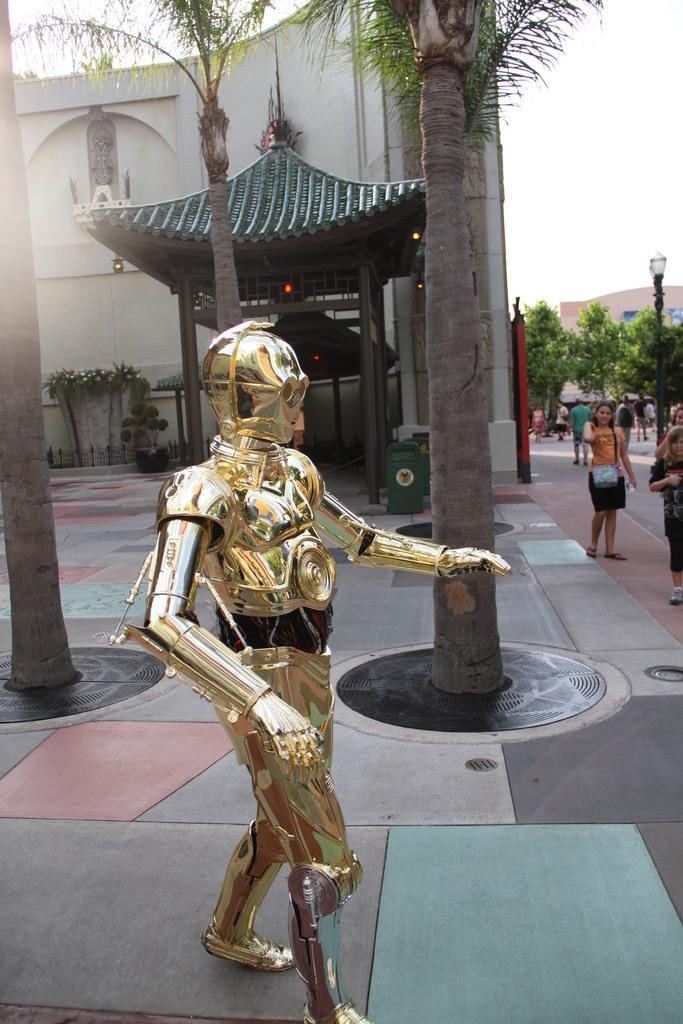What is the main object in the picture? There is a metal Armour in the picture. What can be seen in the background of the picture? There are people, trees, a building, and the clear sky in the background of the picture. How many times does the spring appear in the picture? There is no spring present in the picture. What type of brake can be seen on the metal Armour? There is no brake visible on the metal Armour in the picture. 